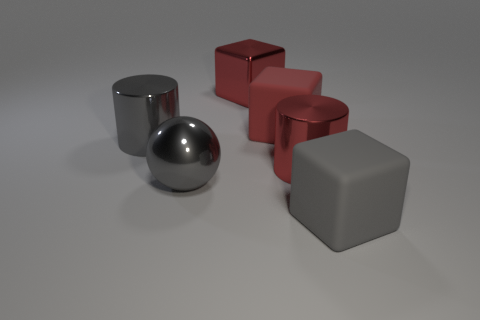Add 1 big gray rubber things. How many objects exist? 7 Subtract all cylinders. How many objects are left? 4 Subtract 1 gray cubes. How many objects are left? 5 Subtract all big red spheres. Subtract all red metal blocks. How many objects are left? 5 Add 6 big metal blocks. How many big metal blocks are left? 7 Add 2 red metallic cubes. How many red metallic cubes exist? 3 